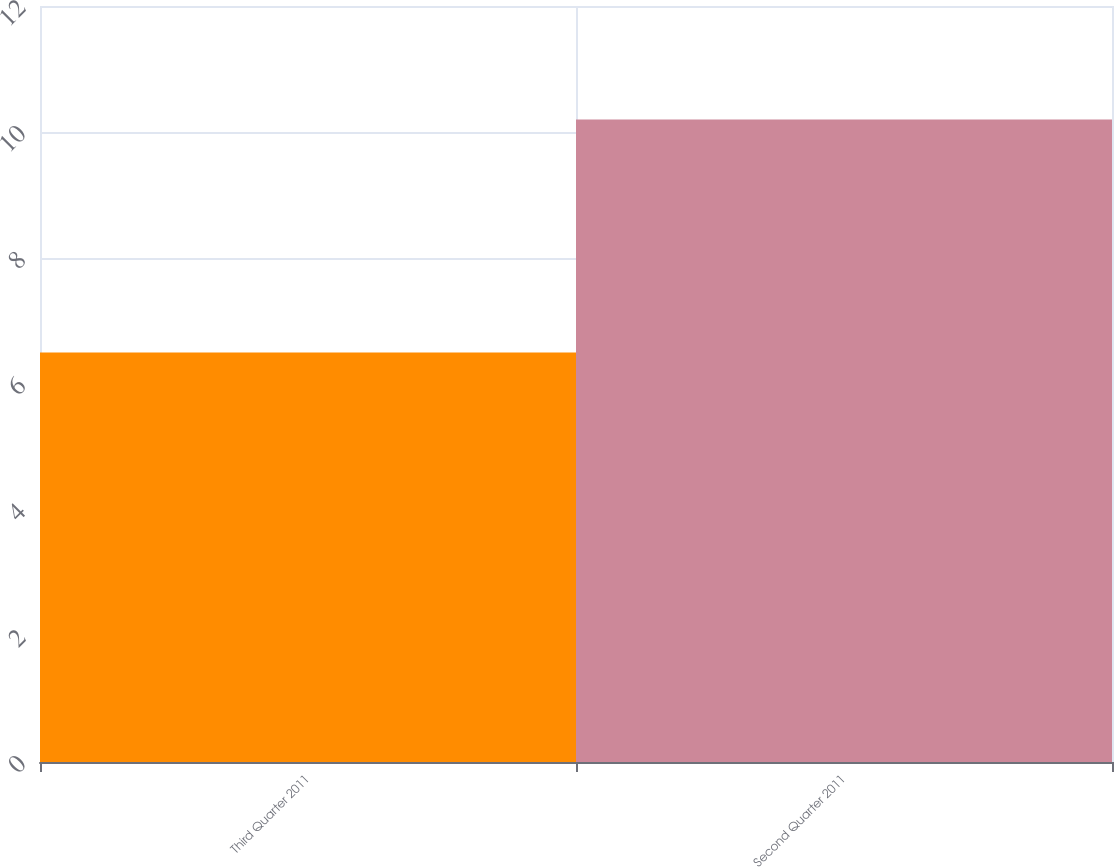Convert chart to OTSL. <chart><loc_0><loc_0><loc_500><loc_500><bar_chart><fcel>Third Quarter 2011<fcel>Second Quarter 2011<nl><fcel>6.5<fcel>10.2<nl></chart> 